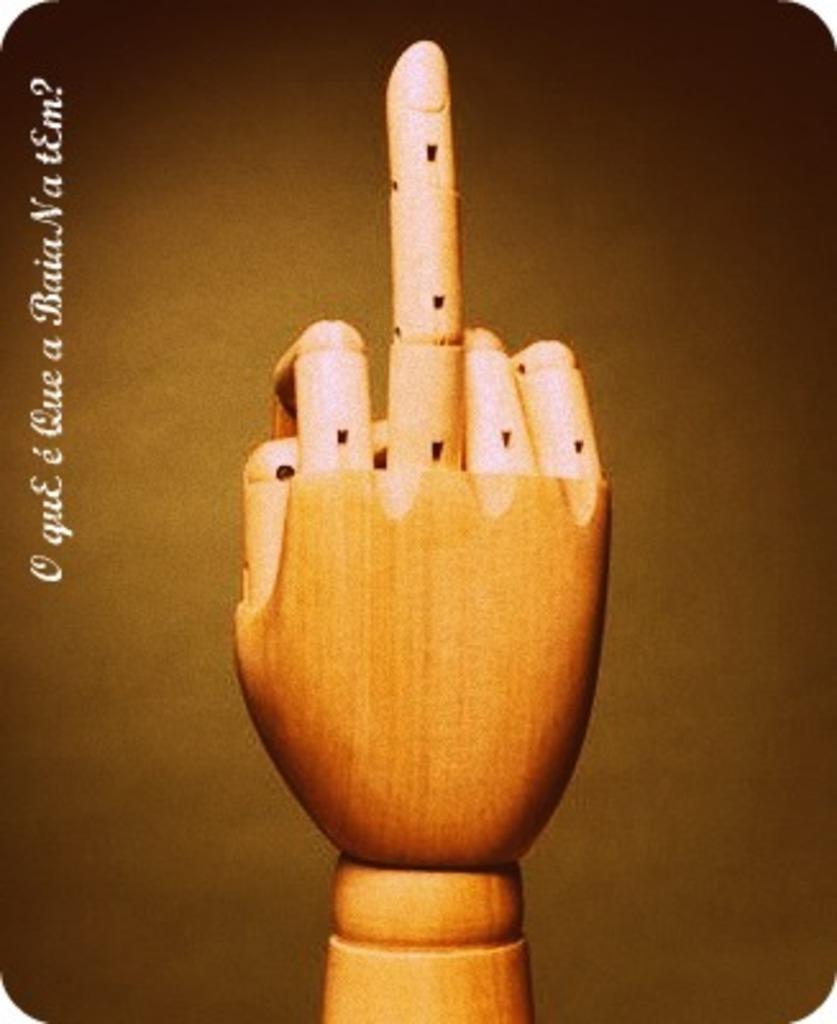How would you summarize this image in a sentence or two? In this image, we can see a wooden hand pointing the middle finger. We can see a watermark on the left side. 